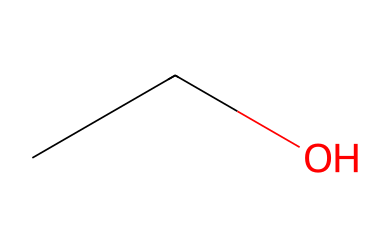What is the chemical name of this compound? The SMILES representation "CCO" corresponds to the molecule ethanol. Ethanol is a simple alcohol, derived from hydrocarbons, and is often used as a solvent.
Answer: ethanol How many carbon atoms are present in the structure? In the SMILES code "CCO," there are two "C" characters, indicating that there are two carbon atoms in the ethanol molecule.
Answer: 2 What type of functional group is present in this molecule? The presence of the -OH (hydroxyl) group in the structure signifies that this molecule is an alcohol, which is characterized by this functional group.
Answer: hydroxyl How many hydrogen atoms are in the ethanol molecule? Each carbon in ethanol can be bonded to enough hydrogen atoms to satisfy carbon's tetravalency. With two carbons, the total number of hydrogens can be determined as follows: C2H5 + OH = 6 hydrogen atoms.
Answer: 6 What is the boiling point range of ethanol? Ethanol has a boiling point of approximately 78 degrees Celsius. This property is important in engineering applications for understanding solvent behavior.
Answer: 78 degrees Celsius Is this solvent polar or nonpolar? The -OH group in ethanol contributes to its polarity, making it a polar solvent. The structure allows for hydrogen bonding, which is a characteristic behavior of polar solvents.
Answer: polar What common applications does ethanol serve as a solvent? Ethanol is commonly used in various applications including personal care products, pharmaceuticals, and as a cleaning agent. Its effectiveness is due to its solvent properties and ability to dissolve both hydrophilic and hydrophobic substances.
Answer: cleaning agent 